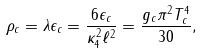Convert formula to latex. <formula><loc_0><loc_0><loc_500><loc_500>\rho _ { c } = \lambda \epsilon _ { c } = \frac { 6 \epsilon _ { c } } { \kappa _ { 4 } ^ { 2 } \ell ^ { 2 } } = \frac { g _ { c } \pi ^ { 2 } T _ { c } ^ { 4 } } { 3 0 } ,</formula> 